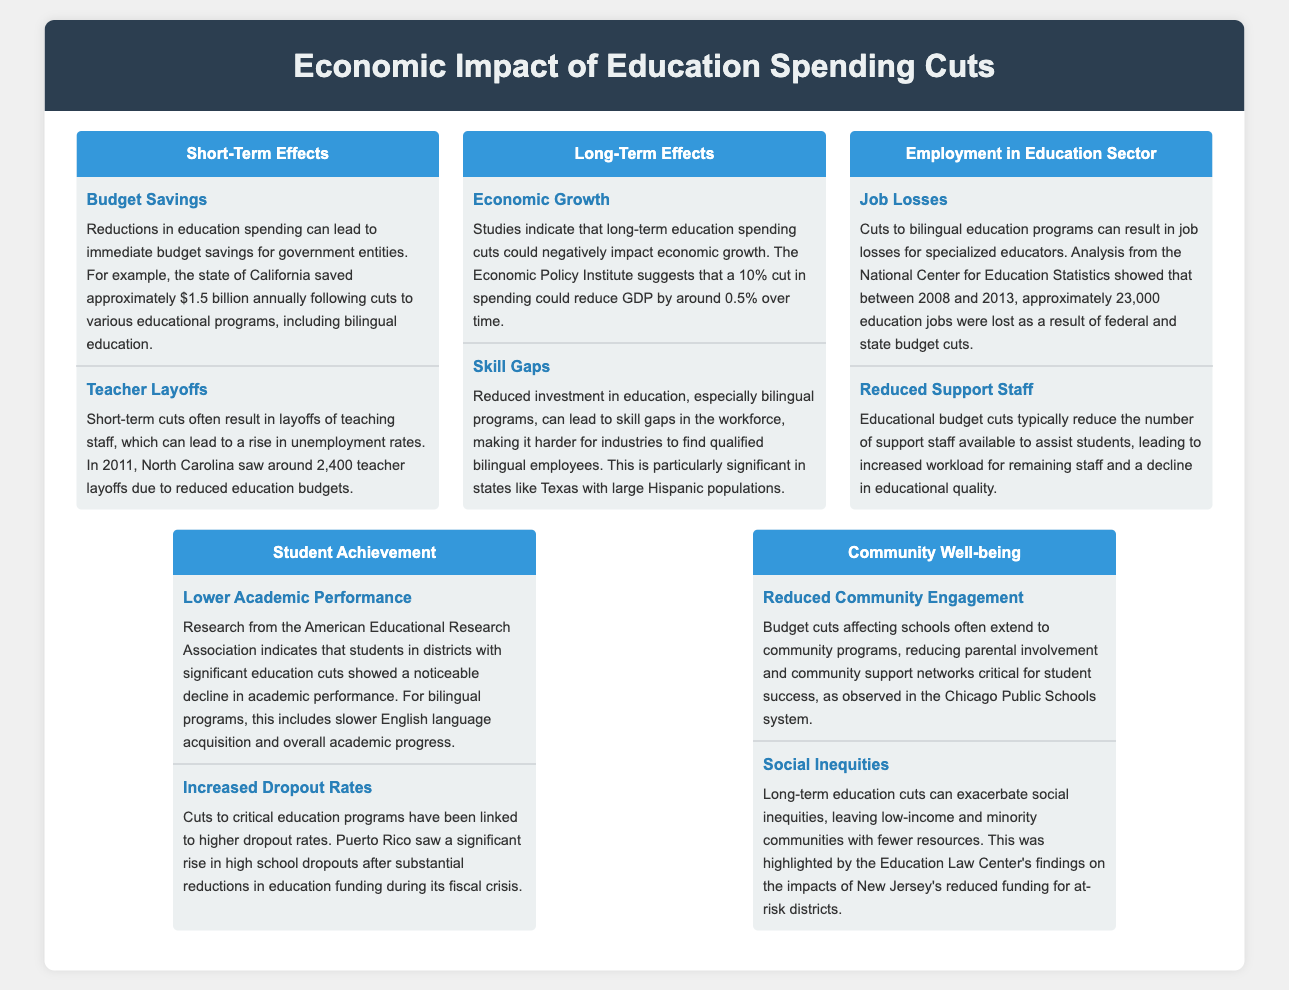What is the annual budget savings for California after education cuts? The document states that California saved approximately $1.5 billion annually after cuts to educational programs, including bilingual education.
Answer: $1.5 billion How many teacher layoffs occurred in North Carolina in 2011? The document mentions that North Carolina experienced around 2,400 teacher layoffs due to reduced education budgets in 2011.
Answer: 2,400 What is the potential reduction in GDP from a 10% education spending cut according to the Economic Policy Institute? The Economic Policy Institute suggests that a 10% cut in spending could reduce GDP by around 0.5% over time.
Answer: 0.5% What was the number of education jobs lost between 2008 and 2013? The document indicates that approximately 23,000 education jobs were lost due to federal and state budget cuts during that period.
Answer: 23,000 What impact does reduced investment in bilingual programs have on the workforce? The document highlights that it can lead to skill gaps in the workforce, making it harder for industries to find qualified bilingual employees.
Answer: Skill gaps What academic performance decline is observed in districts with education cuts? Research indicates that students in districts with significant education cuts showed a noticeable decline in academic performance, particularly in bilingual programs.
Answer: Decline in academic performance What was highlighted by the Education Law Center regarding social inequities? The Education Law Center's findings show that long-term education cuts can exacerbate social inequities, particularly affecting low-income and minority communities.
Answer: Social inequities Which community aspect is affected by budget cuts to schools? Budget cuts affecting schools often result in reduced community engagement, affecting parental involvement and community support networks critical for student success.
Answer: Reduced community engagement 